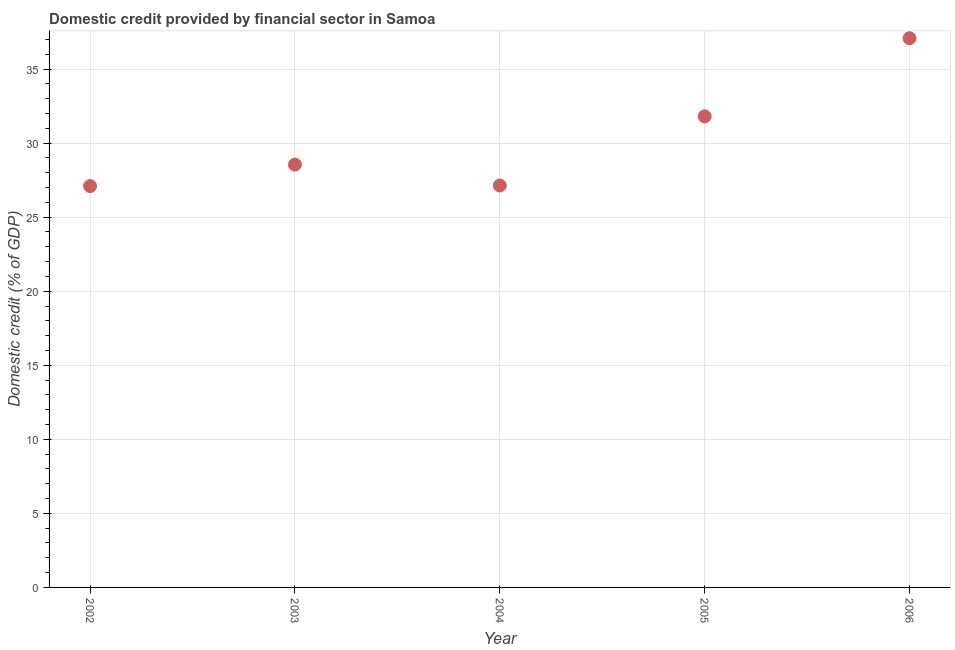What is the domestic credit provided by financial sector in 2003?
Ensure brevity in your answer.  28.55. Across all years, what is the maximum domestic credit provided by financial sector?
Your response must be concise. 37.08. Across all years, what is the minimum domestic credit provided by financial sector?
Your answer should be very brief. 27.1. What is the sum of the domestic credit provided by financial sector?
Ensure brevity in your answer.  151.67. What is the difference between the domestic credit provided by financial sector in 2002 and 2003?
Keep it short and to the point. -1.45. What is the average domestic credit provided by financial sector per year?
Make the answer very short. 30.33. What is the median domestic credit provided by financial sector?
Provide a short and direct response. 28.55. In how many years, is the domestic credit provided by financial sector greater than 18 %?
Make the answer very short. 5. What is the ratio of the domestic credit provided by financial sector in 2004 to that in 2005?
Offer a very short reply. 0.85. What is the difference between the highest and the second highest domestic credit provided by financial sector?
Offer a terse response. 5.28. What is the difference between the highest and the lowest domestic credit provided by financial sector?
Offer a very short reply. 9.98. In how many years, is the domestic credit provided by financial sector greater than the average domestic credit provided by financial sector taken over all years?
Make the answer very short. 2. Does the domestic credit provided by financial sector monotonically increase over the years?
Offer a terse response. No. How many dotlines are there?
Give a very brief answer. 1. Does the graph contain grids?
Keep it short and to the point. Yes. What is the title of the graph?
Offer a terse response. Domestic credit provided by financial sector in Samoa. What is the label or title of the Y-axis?
Keep it short and to the point. Domestic credit (% of GDP). What is the Domestic credit (% of GDP) in 2002?
Offer a very short reply. 27.1. What is the Domestic credit (% of GDP) in 2003?
Make the answer very short. 28.55. What is the Domestic credit (% of GDP) in 2004?
Your answer should be compact. 27.14. What is the Domestic credit (% of GDP) in 2005?
Offer a terse response. 31.81. What is the Domestic credit (% of GDP) in 2006?
Your answer should be very brief. 37.08. What is the difference between the Domestic credit (% of GDP) in 2002 and 2003?
Your answer should be compact. -1.45. What is the difference between the Domestic credit (% of GDP) in 2002 and 2004?
Give a very brief answer. -0.04. What is the difference between the Domestic credit (% of GDP) in 2002 and 2005?
Give a very brief answer. -4.71. What is the difference between the Domestic credit (% of GDP) in 2002 and 2006?
Offer a very short reply. -9.98. What is the difference between the Domestic credit (% of GDP) in 2003 and 2004?
Provide a short and direct response. 1.41. What is the difference between the Domestic credit (% of GDP) in 2003 and 2005?
Keep it short and to the point. -3.26. What is the difference between the Domestic credit (% of GDP) in 2003 and 2006?
Provide a short and direct response. -8.53. What is the difference between the Domestic credit (% of GDP) in 2004 and 2005?
Give a very brief answer. -4.67. What is the difference between the Domestic credit (% of GDP) in 2004 and 2006?
Keep it short and to the point. -9.95. What is the difference between the Domestic credit (% of GDP) in 2005 and 2006?
Make the answer very short. -5.28. What is the ratio of the Domestic credit (% of GDP) in 2002 to that in 2003?
Your response must be concise. 0.95. What is the ratio of the Domestic credit (% of GDP) in 2002 to that in 2004?
Make the answer very short. 1. What is the ratio of the Domestic credit (% of GDP) in 2002 to that in 2005?
Provide a short and direct response. 0.85. What is the ratio of the Domestic credit (% of GDP) in 2002 to that in 2006?
Keep it short and to the point. 0.73. What is the ratio of the Domestic credit (% of GDP) in 2003 to that in 2004?
Offer a very short reply. 1.05. What is the ratio of the Domestic credit (% of GDP) in 2003 to that in 2005?
Offer a very short reply. 0.9. What is the ratio of the Domestic credit (% of GDP) in 2003 to that in 2006?
Your answer should be compact. 0.77. What is the ratio of the Domestic credit (% of GDP) in 2004 to that in 2005?
Offer a terse response. 0.85. What is the ratio of the Domestic credit (% of GDP) in 2004 to that in 2006?
Offer a terse response. 0.73. What is the ratio of the Domestic credit (% of GDP) in 2005 to that in 2006?
Provide a short and direct response. 0.86. 